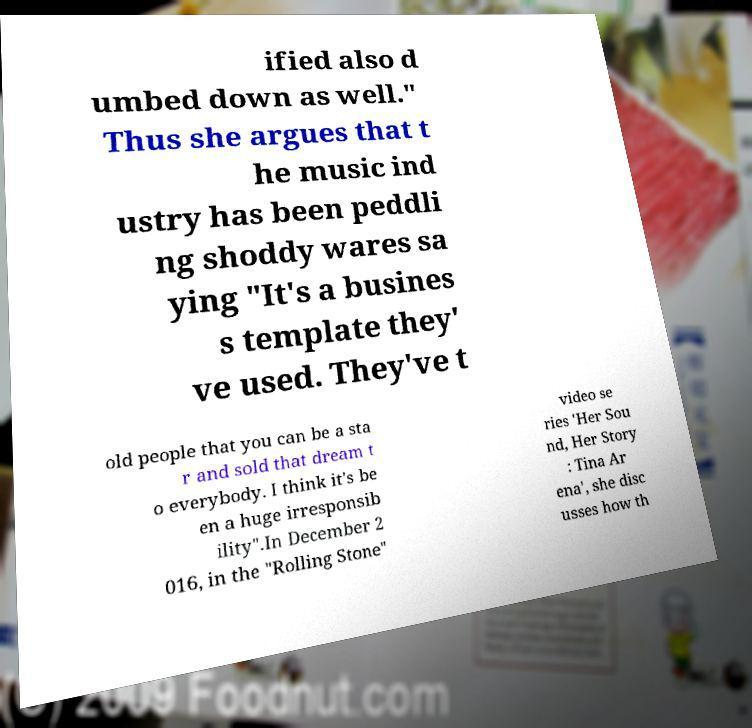Can you accurately transcribe the text from the provided image for me? ified also d umbed down as well." Thus she argues that t he music ind ustry has been peddli ng shoddy wares sa ying "It's a busines s template they' ve used. They've t old people that you can be a sta r and sold that dream t o everybody. I think it's be en a huge irresponsib ility".In December 2 016, in the "Rolling Stone" video se ries 'Her Sou nd, Her Story : Tina Ar ena', she disc usses how th 